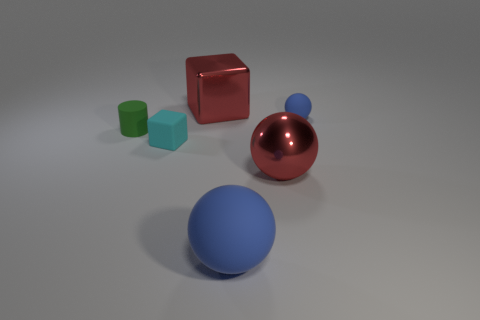Add 1 large red cubes. How many objects exist? 7 Subtract all cylinders. How many objects are left? 5 Subtract all blue rubber balls. Subtract all cylinders. How many objects are left? 3 Add 4 tiny rubber cylinders. How many tiny rubber cylinders are left? 5 Add 5 green matte blocks. How many green matte blocks exist? 5 Subtract 0 green blocks. How many objects are left? 6 